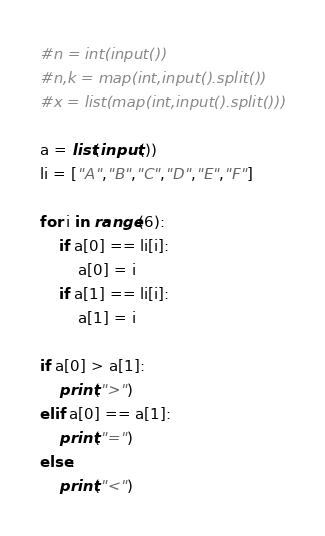<code> <loc_0><loc_0><loc_500><loc_500><_Python_>#n = int(input())
#n,k = map(int,input().split())
#x = list(map(int,input().split()))

a = list(input())
li = ["A","B","C","D","E","F"]

for i in range(6):
    if a[0] == li[i]:
        a[0] = i
    if a[1] == li[i]:
        a[1] = i

if a[0] > a[1]:
    print(">")
elif a[0] == a[1]:
    print("=")
else:
    print("<")


</code> 